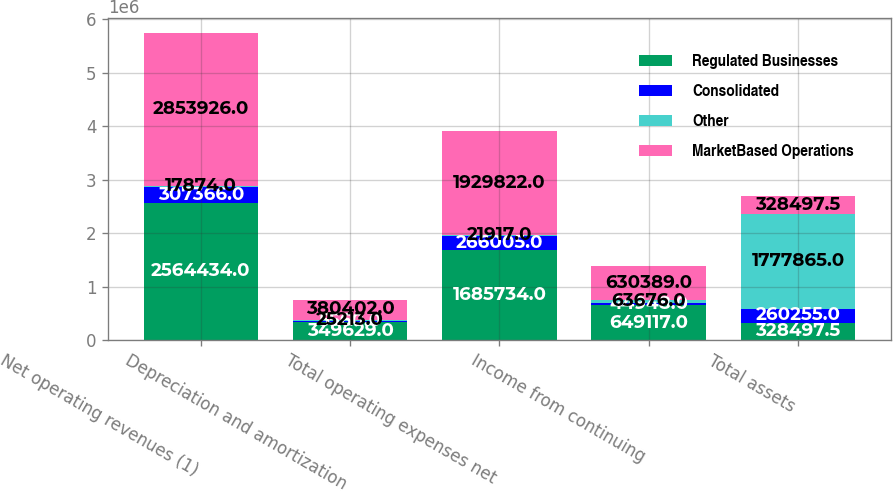Convert chart to OTSL. <chart><loc_0><loc_0><loc_500><loc_500><stacked_bar_chart><ecel><fcel>Net operating revenues (1)<fcel>Depreciation and amortization<fcel>Total operating expenses net<fcel>Income from continuing<fcel>Total assets<nl><fcel>Regulated Businesses<fcel>2.56443e+06<fcel>349629<fcel>1.68573e+06<fcel>649117<fcel>328498<nl><fcel>Consolidated<fcel>307366<fcel>5560<fcel>266005<fcel>44948<fcel>260255<nl><fcel>Other<fcel>17874<fcel>25213<fcel>21917<fcel>63676<fcel>1.77786e+06<nl><fcel>MarketBased Operations<fcel>2.85393e+06<fcel>380402<fcel>1.92982e+06<fcel>630389<fcel>328498<nl></chart> 